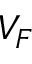<formula> <loc_0><loc_0><loc_500><loc_500>V _ { F }</formula> 